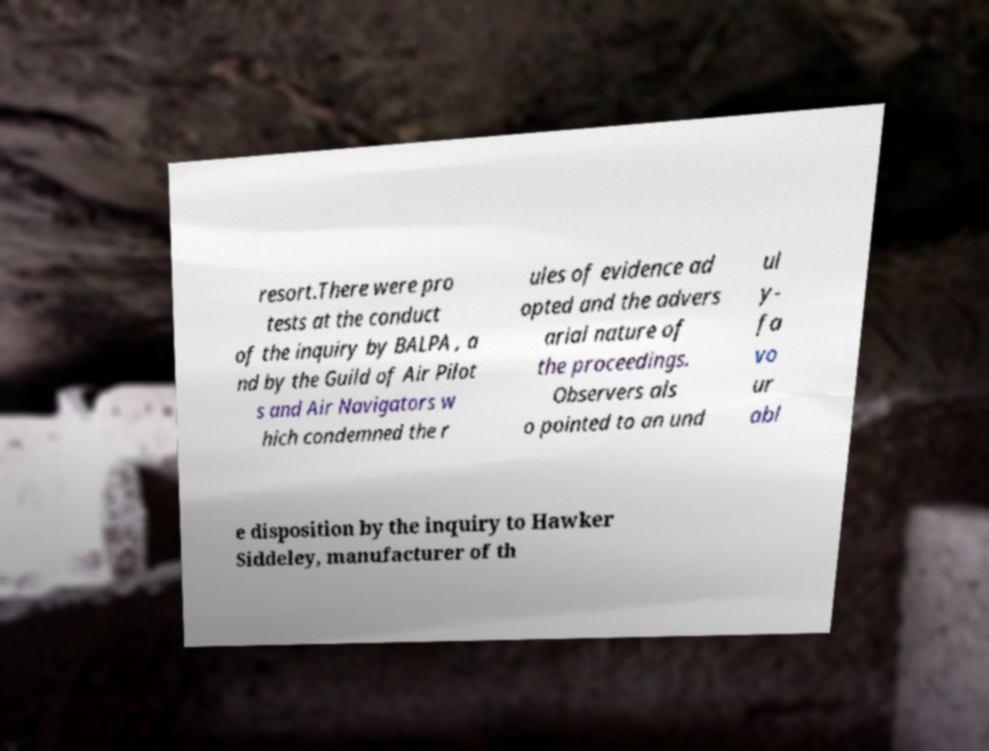What messages or text are displayed in this image? I need them in a readable, typed format. resort.There were pro tests at the conduct of the inquiry by BALPA , a nd by the Guild of Air Pilot s and Air Navigators w hich condemned the r ules of evidence ad opted and the advers arial nature of the proceedings. Observers als o pointed to an und ul y- fa vo ur abl e disposition by the inquiry to Hawker Siddeley, manufacturer of th 